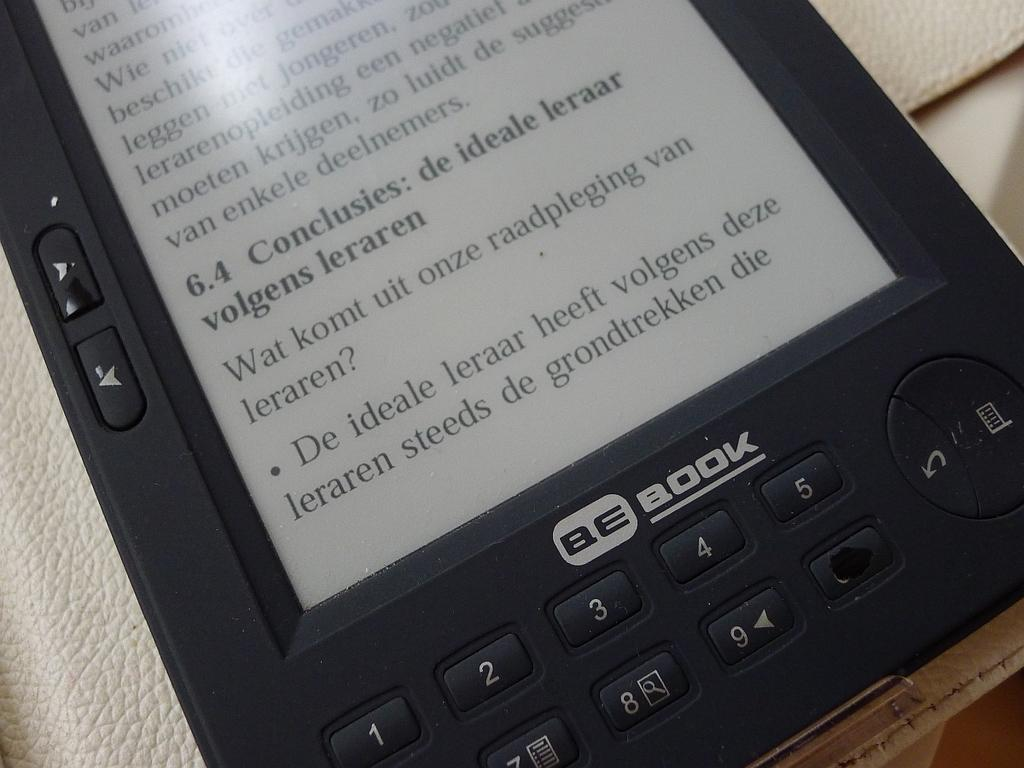<image>
Write a terse but informative summary of the picture. An small black electronic reader is called a BeBook. 